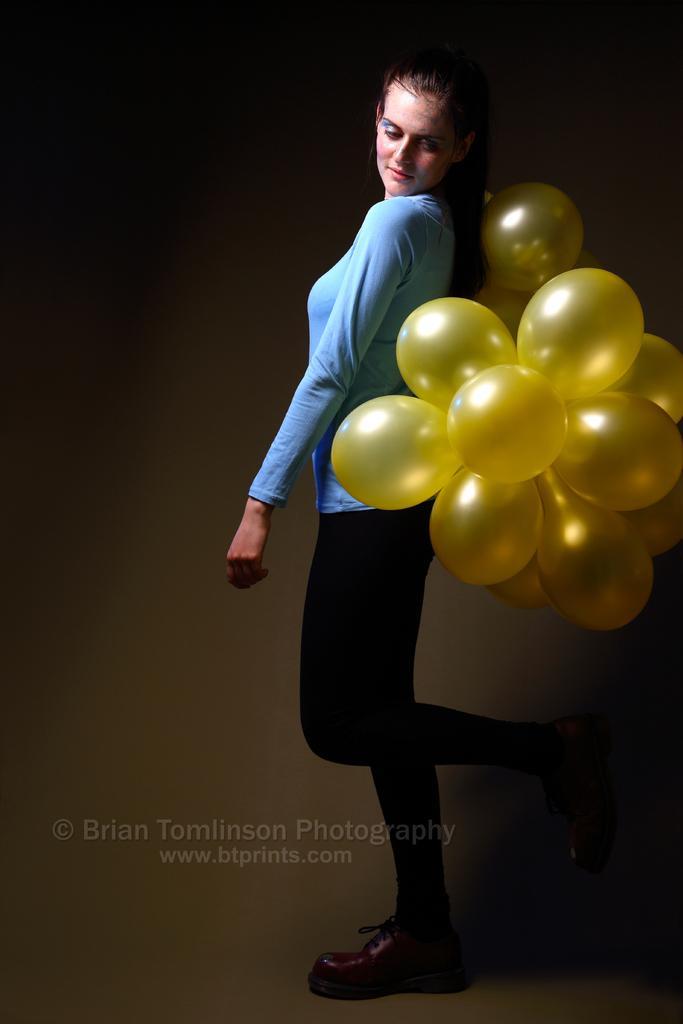Could you give a brief overview of what you see in this image? In this image, we can see a woman is standing and looking towards balloons. Here we can see a watermark in the image. Background we can see brown color. 